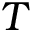<formula> <loc_0><loc_0><loc_500><loc_500>T</formula> 